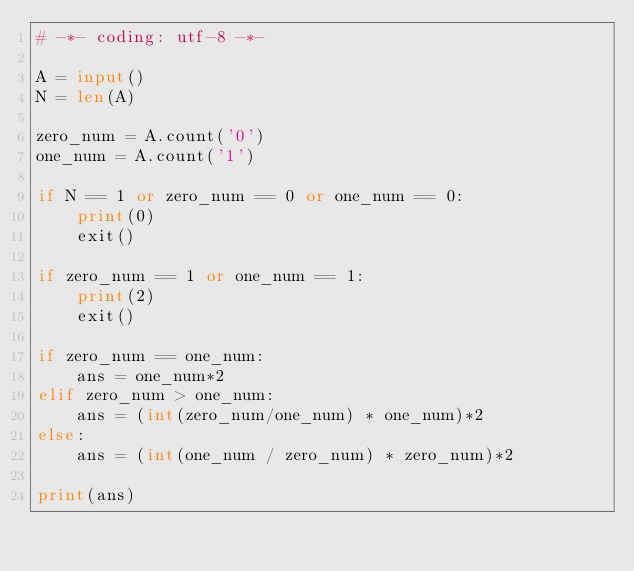Convert code to text. <code><loc_0><loc_0><loc_500><loc_500><_Python_># -*- coding: utf-8 -*-

A = input()
N = len(A)

zero_num = A.count('0')
one_num = A.count('1')

if N == 1 or zero_num == 0 or one_num == 0:
    print(0)
    exit()

if zero_num == 1 or one_num == 1:
    print(2)
    exit()

if zero_num == one_num:
    ans = one_num*2
elif zero_num > one_num:
    ans = (int(zero_num/one_num) * one_num)*2
else:
    ans = (int(one_num / zero_num) * zero_num)*2

print(ans)</code> 